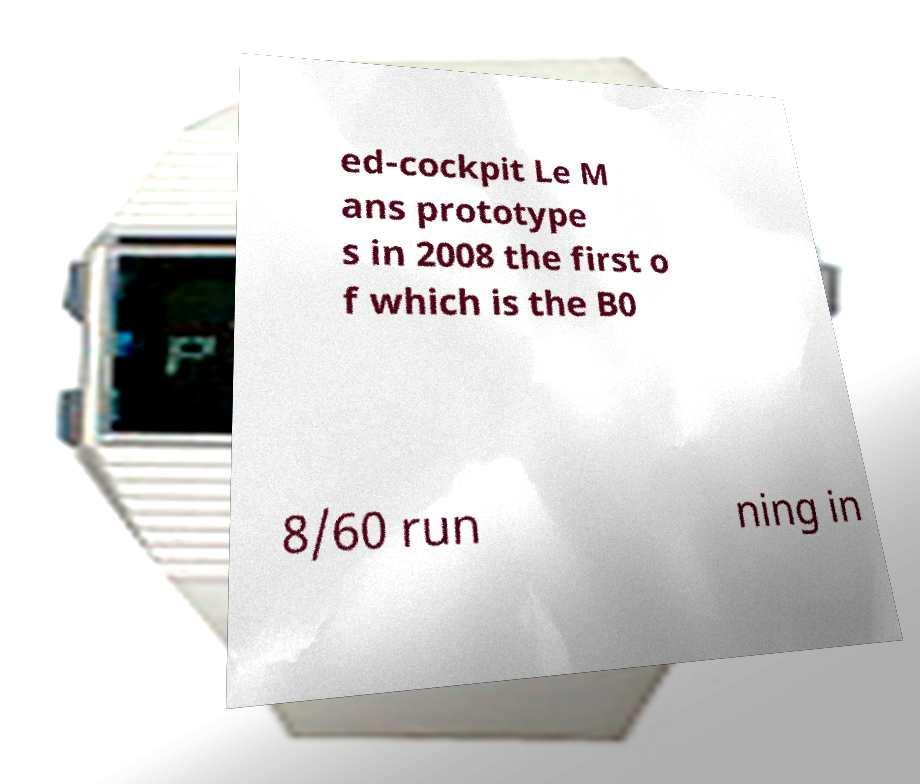Please identify and transcribe the text found in this image. ed-cockpit Le M ans prototype s in 2008 the first o f which is the B0 8/60 run ning in 